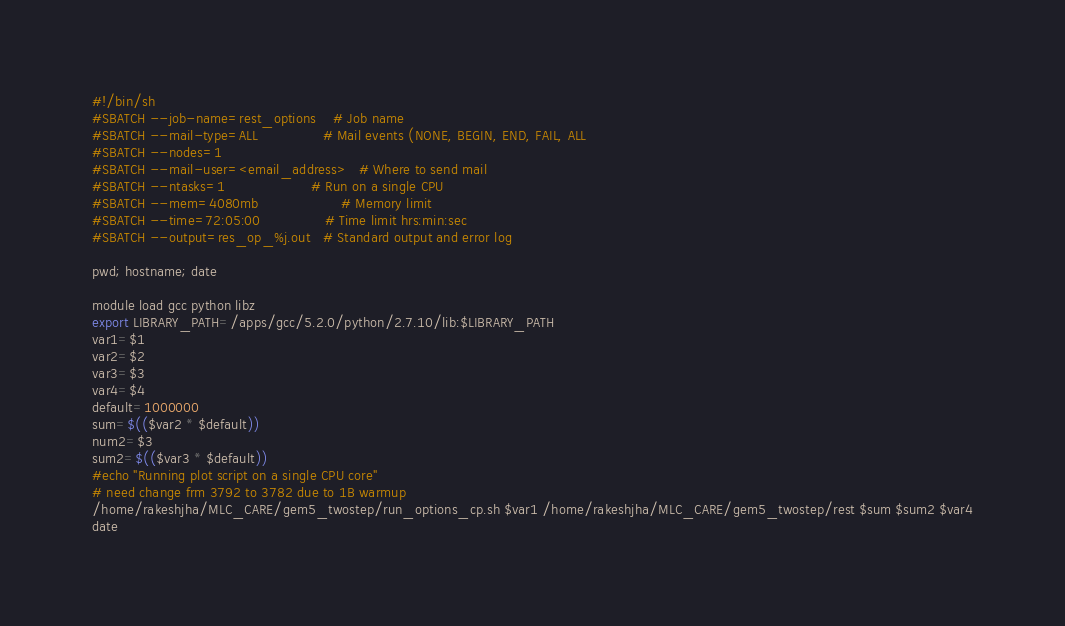<code> <loc_0><loc_0><loc_500><loc_500><_Bash_>#!/bin/sh
#SBATCH --job-name=rest_options    # Job name
#SBATCH --mail-type=ALL               # Mail events (NONE, BEGIN, END, FAIL, ALL
#SBATCH --nodes=1
#SBATCH --mail-user=<email_address>   # Where to send mail	
#SBATCH --ntasks=1                    # Run on a single CPU
#SBATCH --mem=4080mb                   # Memory limit
#SBATCH --time=72:05:00               # Time limit hrs:min:sec
#SBATCH --output=res_op_%j.out   # Standard output and error log
 
pwd; hostname; date
 
module load gcc python libz
export LIBRARY_PATH=/apps/gcc/5.2.0/python/2.7.10/lib:$LIBRARY_PATH
var1=$1
var2=$2
var3=$3 
var4=$4
default=1000000
sum=$(($var2 * $default))
num2=$3
sum2=$(($var3 * $default))
#echo "Running plot script on a single CPU core"
# need change frm 3792 to 3782 due to 1B warmup
/home/rakeshjha/MLC_CARE/gem5_twostep/run_options_cp.sh $var1 /home/rakeshjha/MLC_CARE/gem5_twostep/rest $sum $sum2 $var4
date
</code> 